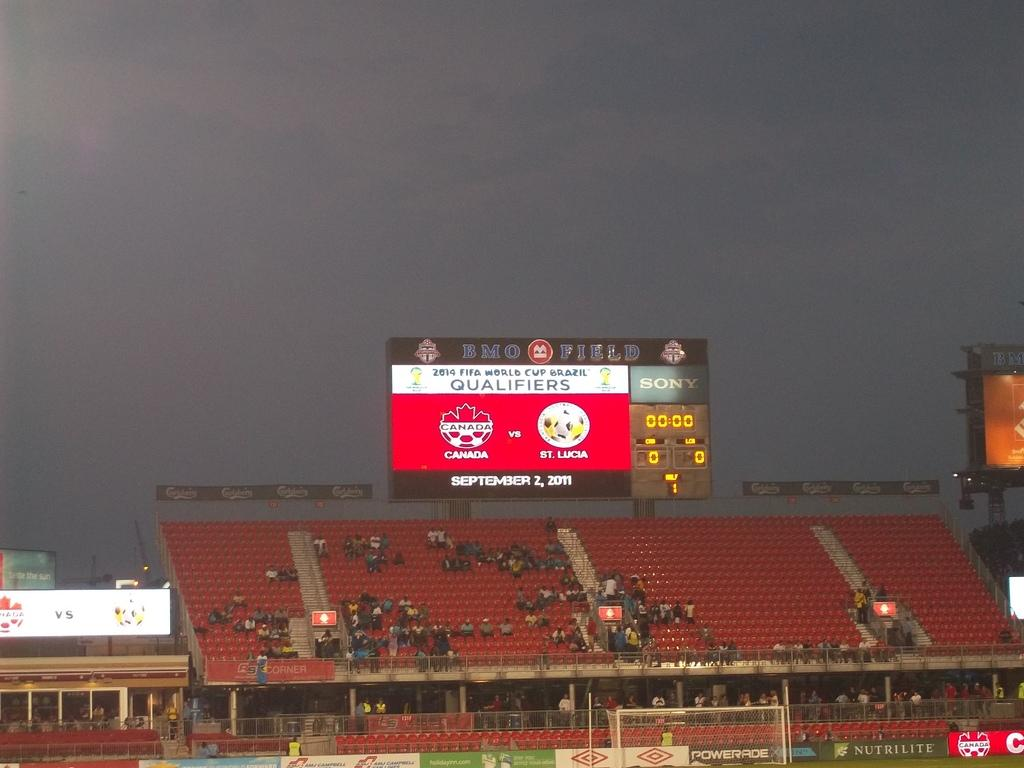<image>
Write a terse but informative summary of the picture. stadium that is featuring world cup qualifying game between canada and st lucia 